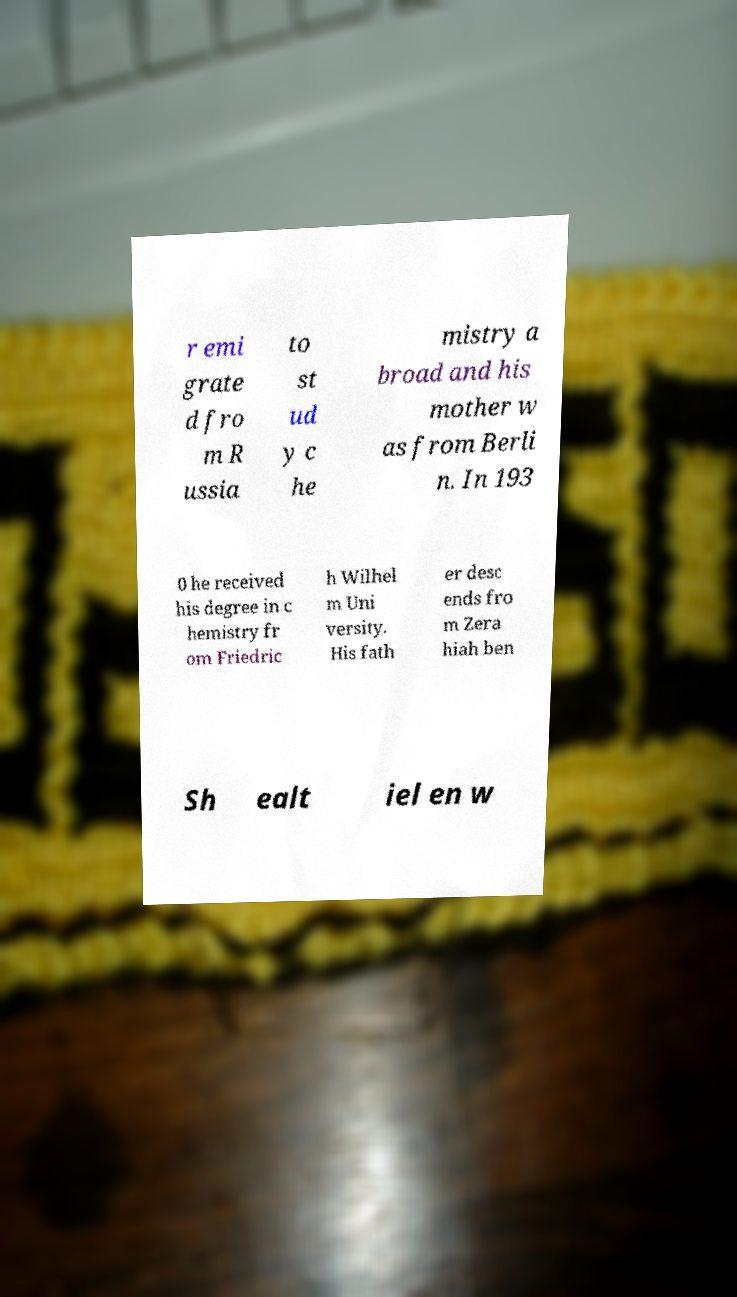I need the written content from this picture converted into text. Can you do that? r emi grate d fro m R ussia to st ud y c he mistry a broad and his mother w as from Berli n. In 193 0 he received his degree in c hemistry fr om Friedric h Wilhel m Uni versity. His fath er desc ends fro m Zera hiah ben Sh ealt iel en w 